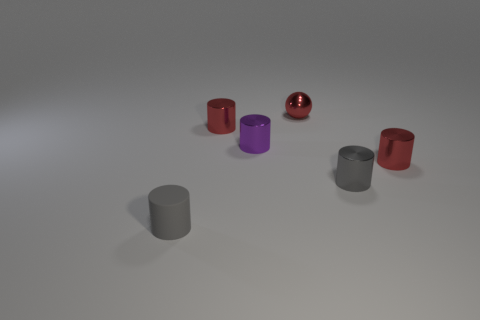What number of tiny purple metallic objects are in front of the small gray matte cylinder?
Provide a short and direct response. 0. Is there a tiny purple cylinder that has the same material as the sphere?
Ensure brevity in your answer.  Yes. What is the material of the sphere that is the same size as the purple metallic object?
Make the answer very short. Metal. What size is the cylinder that is in front of the purple cylinder and on the left side of the red metallic ball?
Your response must be concise. Small. There is a small object that is on the left side of the tiny purple object and to the right of the gray matte thing; what color is it?
Offer a very short reply. Red. Are there fewer rubber things that are right of the gray matte cylinder than metallic cylinders in front of the tiny gray metal object?
Give a very brief answer. No. How many small yellow matte objects are the same shape as the small gray shiny thing?
Ensure brevity in your answer.  0. There is a red sphere that is made of the same material as the purple cylinder; what is its size?
Provide a short and direct response. Small. What color is the thing in front of the tiny gray object behind the small rubber object?
Ensure brevity in your answer.  Gray. There is a tiny gray matte thing; is it the same shape as the small gray object that is behind the small gray rubber cylinder?
Your response must be concise. Yes. 